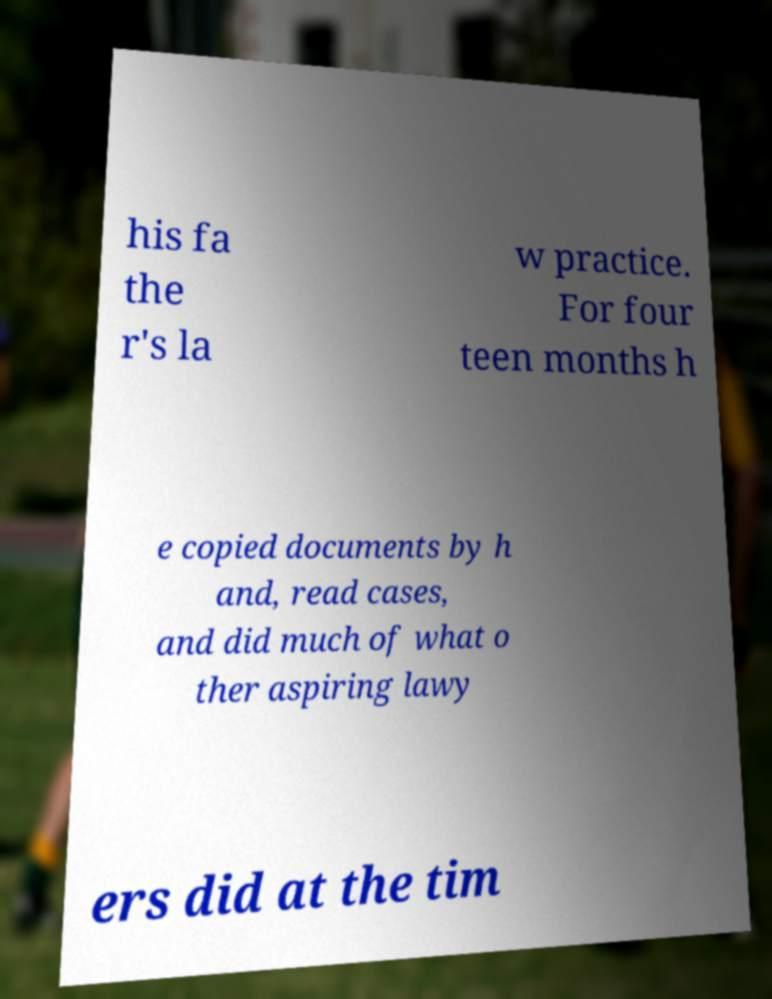Please identify and transcribe the text found in this image. his fa the r's la w practice. For four teen months h e copied documents by h and, read cases, and did much of what o ther aspiring lawy ers did at the tim 